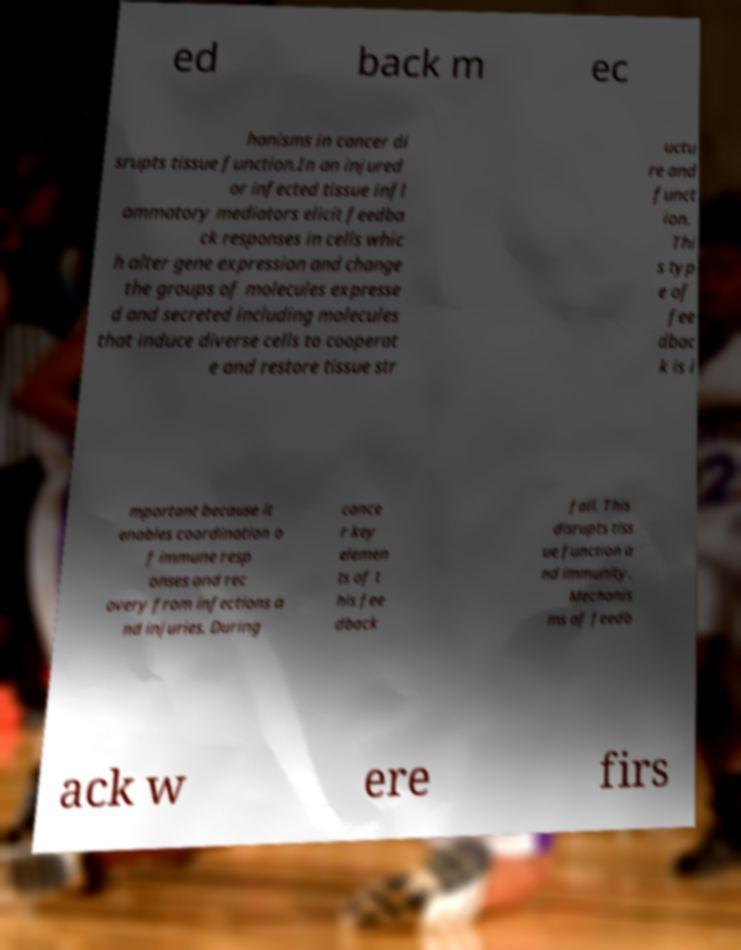Can you read and provide the text displayed in the image?This photo seems to have some interesting text. Can you extract and type it out for me? ed back m ec hanisms in cancer di srupts tissue function.In an injured or infected tissue infl ammatory mediators elicit feedba ck responses in cells whic h alter gene expression and change the groups of molecules expresse d and secreted including molecules that induce diverse cells to cooperat e and restore tissue str uctu re and funct ion. Thi s typ e of fee dbac k is i mportant because it enables coordination o f immune resp onses and rec overy from infections a nd injuries. During cance r key elemen ts of t his fee dback fail. This disrupts tiss ue function a nd immunity. Mechanis ms of feedb ack w ere firs 